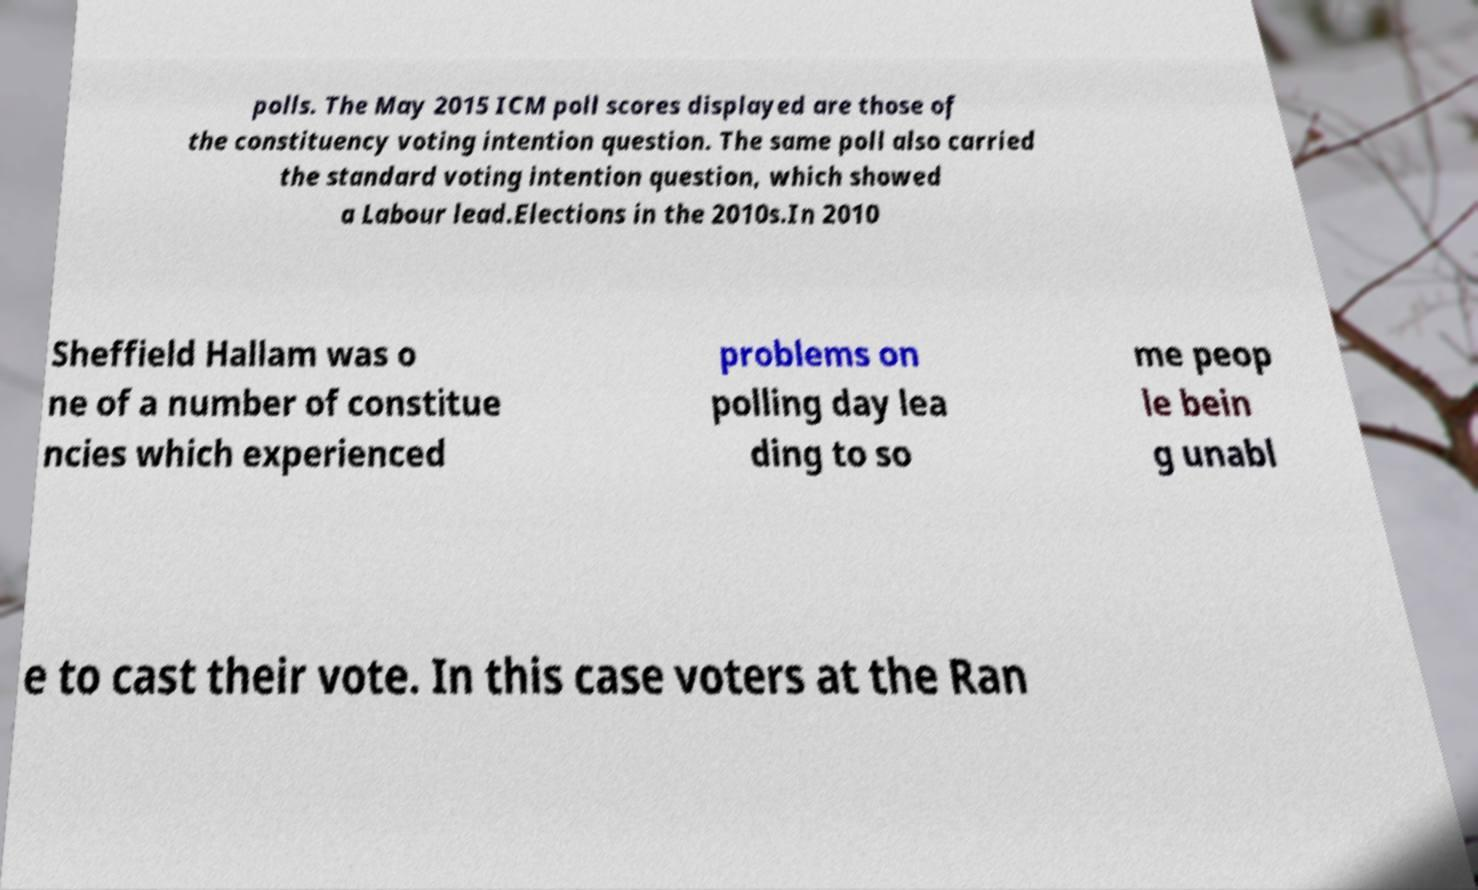Could you assist in decoding the text presented in this image and type it out clearly? polls. The May 2015 ICM poll scores displayed are those of the constituency voting intention question. The same poll also carried the standard voting intention question, which showed a Labour lead.Elections in the 2010s.In 2010 Sheffield Hallam was o ne of a number of constitue ncies which experienced problems on polling day lea ding to so me peop le bein g unabl e to cast their vote. In this case voters at the Ran 